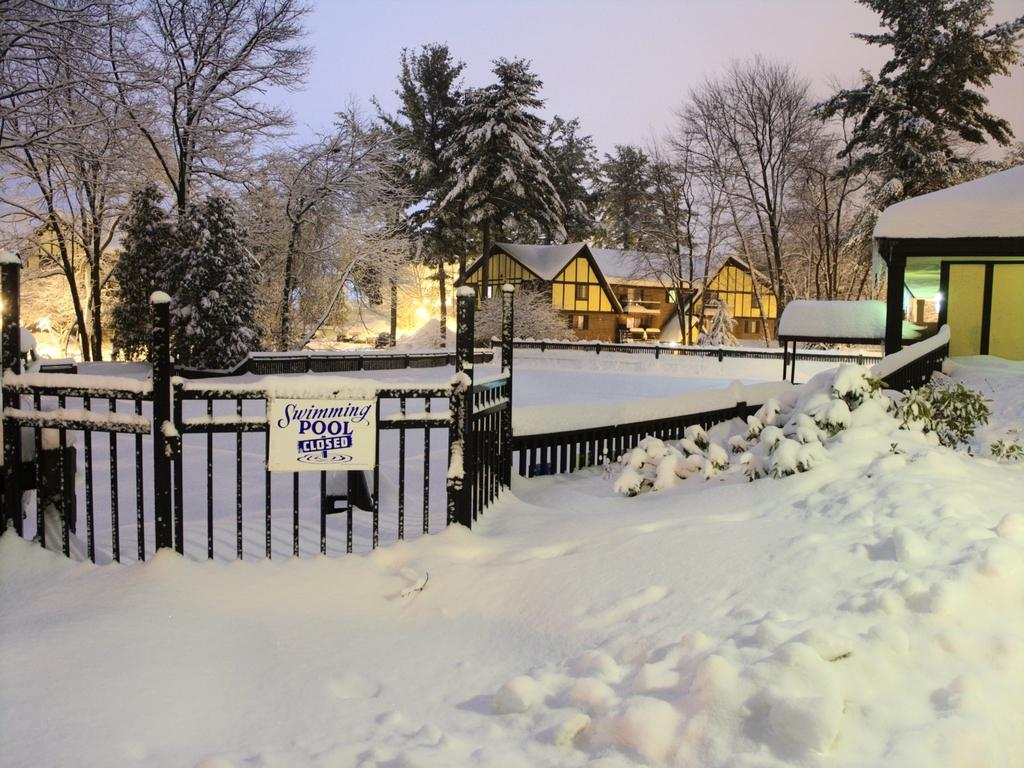What type of structures can be seen in the image? There are houses in the image. What is in front of the houses? There is a fence in front of the houses. What is the weather like in the image? The snow visible in the image suggests a cold or wintery weather. What is visible at the top of the image? The sky is visible at the top of the image. What type of vegetation can be seen in the image? There are trees in the middle of the image. What type of stone is used to build the land in the image? There is no mention of land or stone in the image; it features houses, a fence, snow, sky, and trees. 